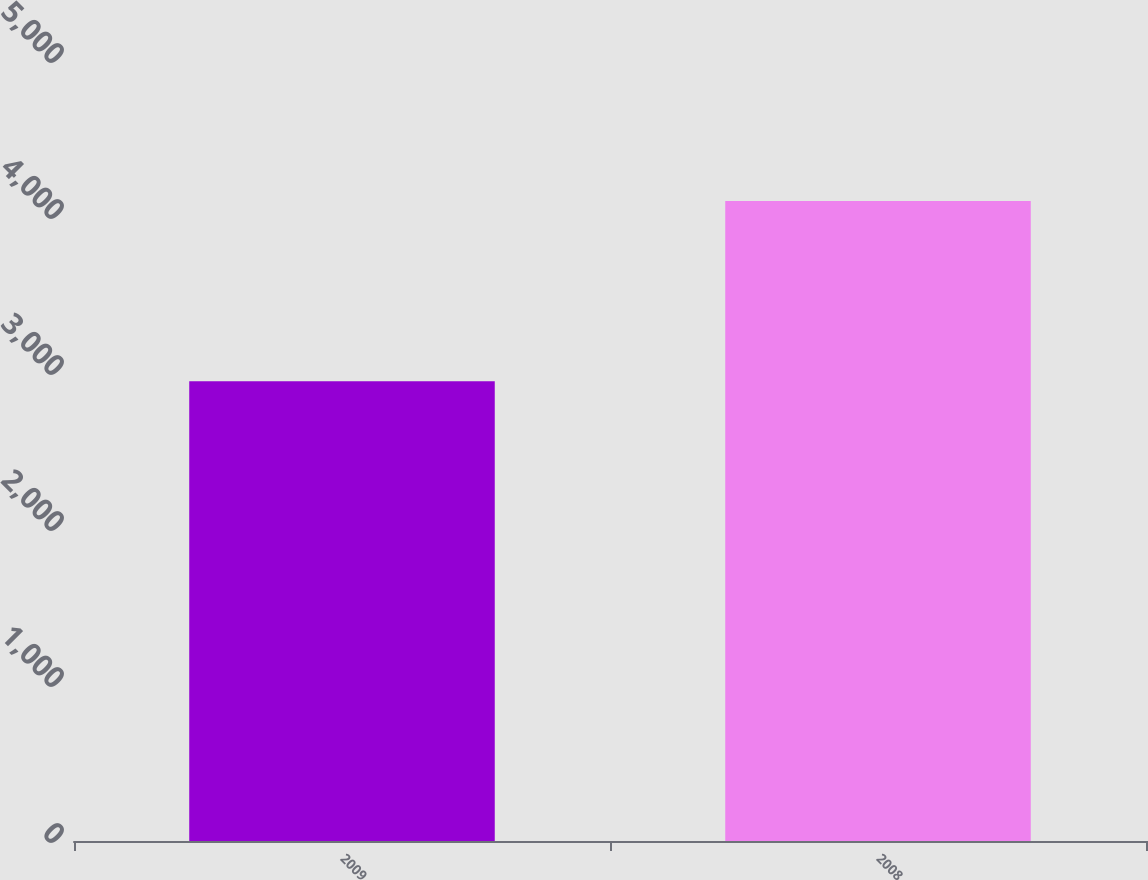Convert chart. <chart><loc_0><loc_0><loc_500><loc_500><bar_chart><fcel>2009<fcel>2008<nl><fcel>2947<fcel>4102<nl></chart> 